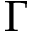<formula> <loc_0><loc_0><loc_500><loc_500>\Gamma</formula> 